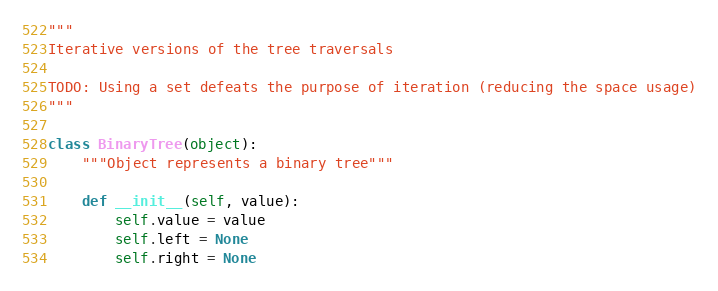<code> <loc_0><loc_0><loc_500><loc_500><_Python_>"""
Iterative versions of the tree traversals

TODO: Using a set defeats the purpose of iteration (reducing the space usage)
"""

class BinaryTree(object):
    """Object represents a binary tree"""

    def __init__(self, value):
        self.value = value
        self.left = None
        self.right = None
</code> 